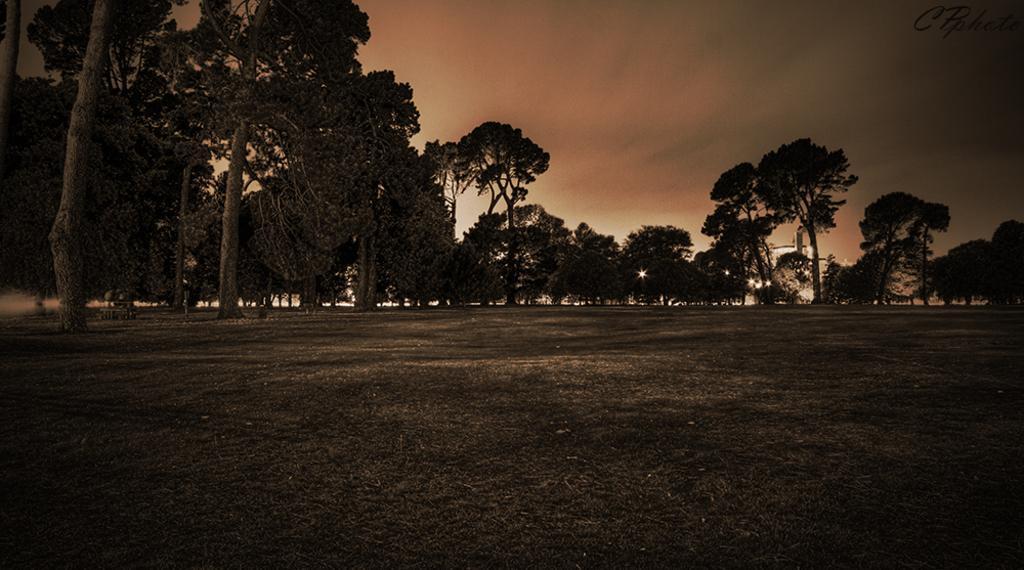In one or two sentences, can you explain what this image depicts? In this picture I can see the open grass ground. In the background I see number of trees and I see the sky. On the top right corner of this image I see the watermark. 